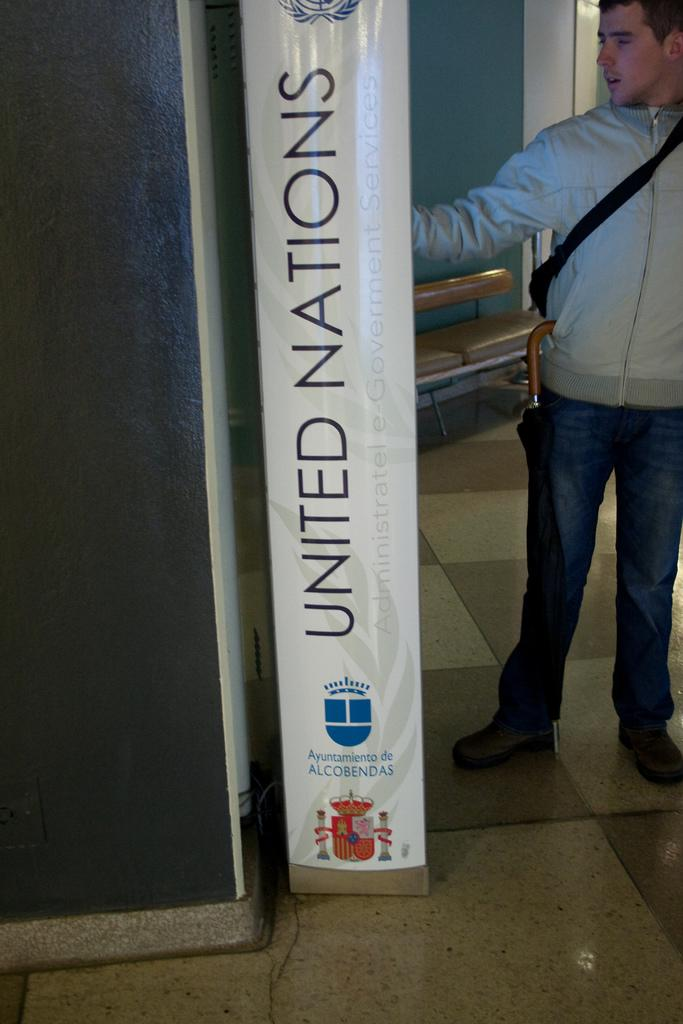<image>
Present a compact description of the photo's key features. A man stands beside a vertical sign with United Nations. 